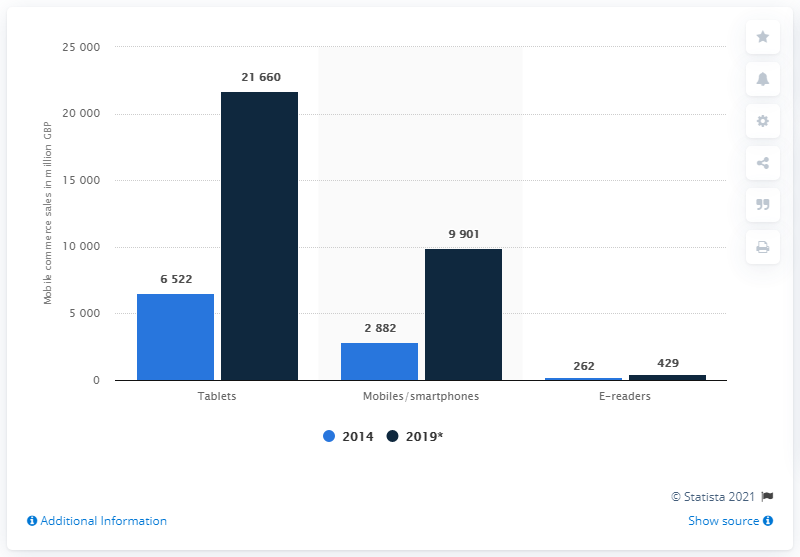Give some essential details in this illustration. According to data from 2014, the total sales generated by mobile and smartphone users in the UK amounted to approximately 2882 British Pounds. 